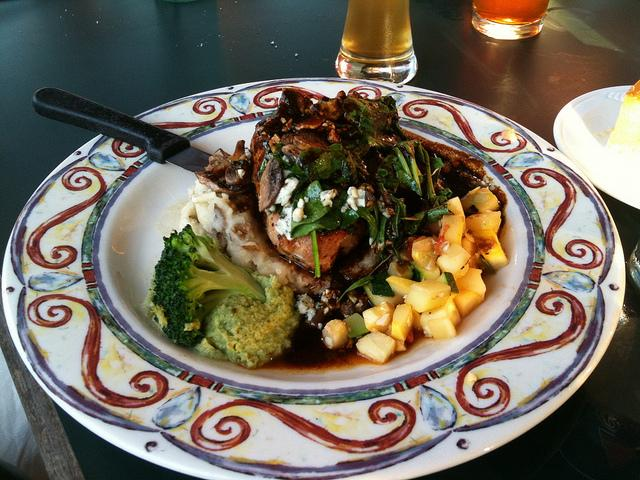What utensil is on the plate? knife 